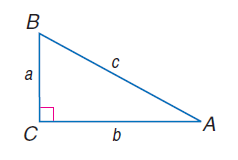Answer the mathemtical geometry problem and directly provide the correct option letter.
Question: a = 14, b = 48, and c = 50, find \tan B.
Choices: A: 3.43 B: 4.8 C: 5.2 D: 6.86 A 